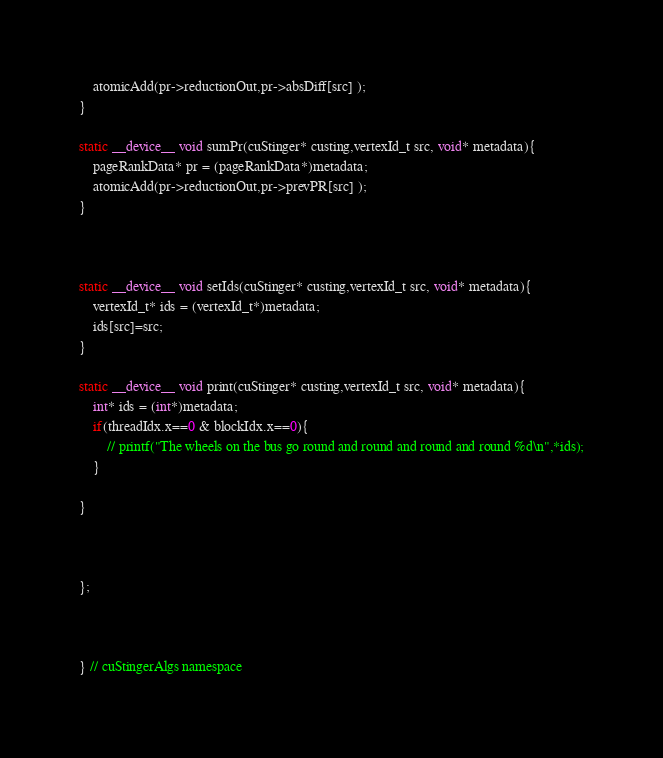<code> <loc_0><loc_0><loc_500><loc_500><_Cuda_>	atomicAdd(pr->reductionOut,pr->absDiff[src] );
}

static __device__ void sumPr(cuStinger* custing,vertexId_t src, void* metadata){
	pageRankData* pr = (pageRankData*)metadata;
	atomicAdd(pr->reductionOut,pr->prevPR[src] );
}



static __device__ void setIds(cuStinger* custing,vertexId_t src, void* metadata){
	vertexId_t* ids = (vertexId_t*)metadata;
	ids[src]=src;
}

static __device__ void print(cuStinger* custing,vertexId_t src, void* metadata){
	int* ids = (int*)metadata;
	if(threadIdx.x==0 & blockIdx.x==0){
		// printf("The wheels on the bus go round and round and round and round %d\n",*ids);
	}

}



};



} // cuStingerAlgs namespace</code> 